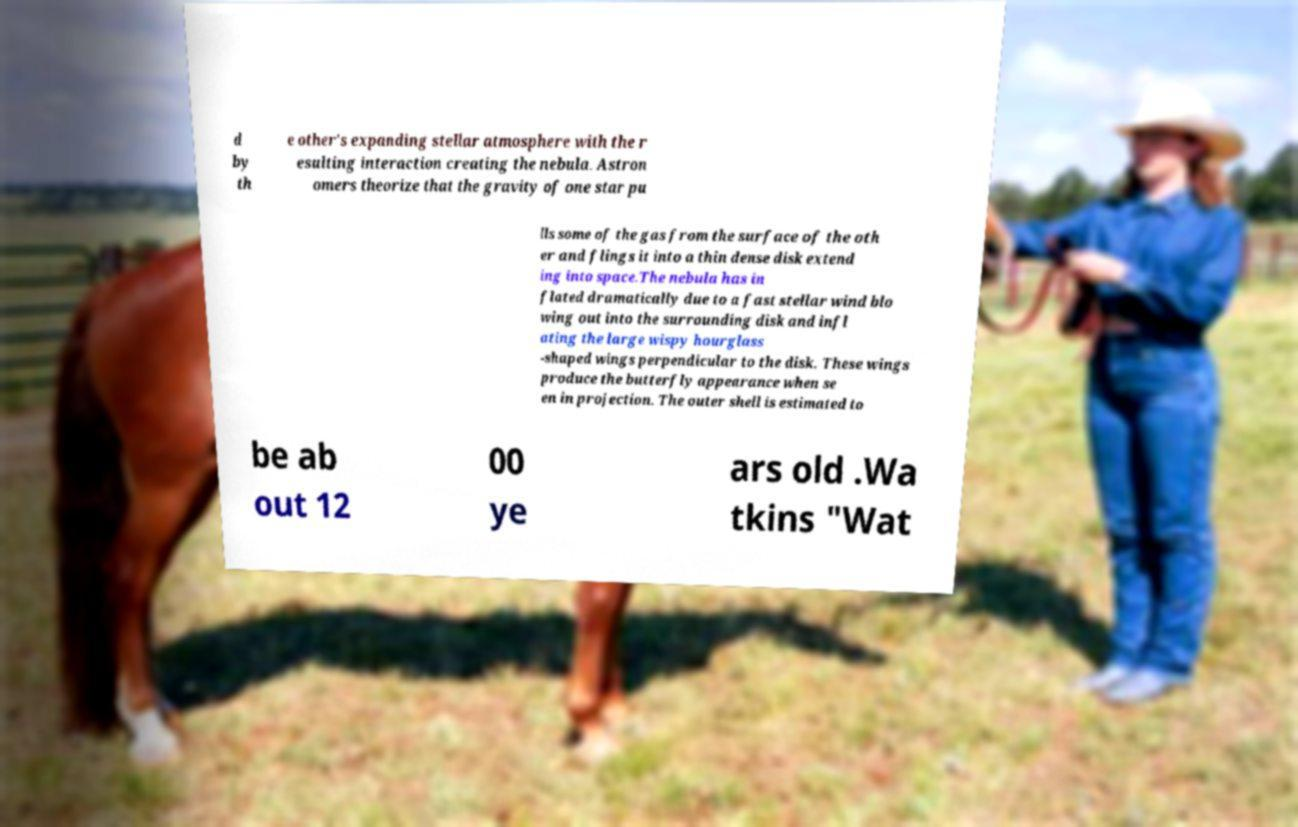Could you extract and type out the text from this image? d by th e other's expanding stellar atmosphere with the r esulting interaction creating the nebula. Astron omers theorize that the gravity of one star pu lls some of the gas from the surface of the oth er and flings it into a thin dense disk extend ing into space.The nebula has in flated dramatically due to a fast stellar wind blo wing out into the surrounding disk and infl ating the large wispy hourglass -shaped wings perpendicular to the disk. These wings produce the butterfly appearance when se en in projection. The outer shell is estimated to be ab out 12 00 ye ars old .Wa tkins "Wat 